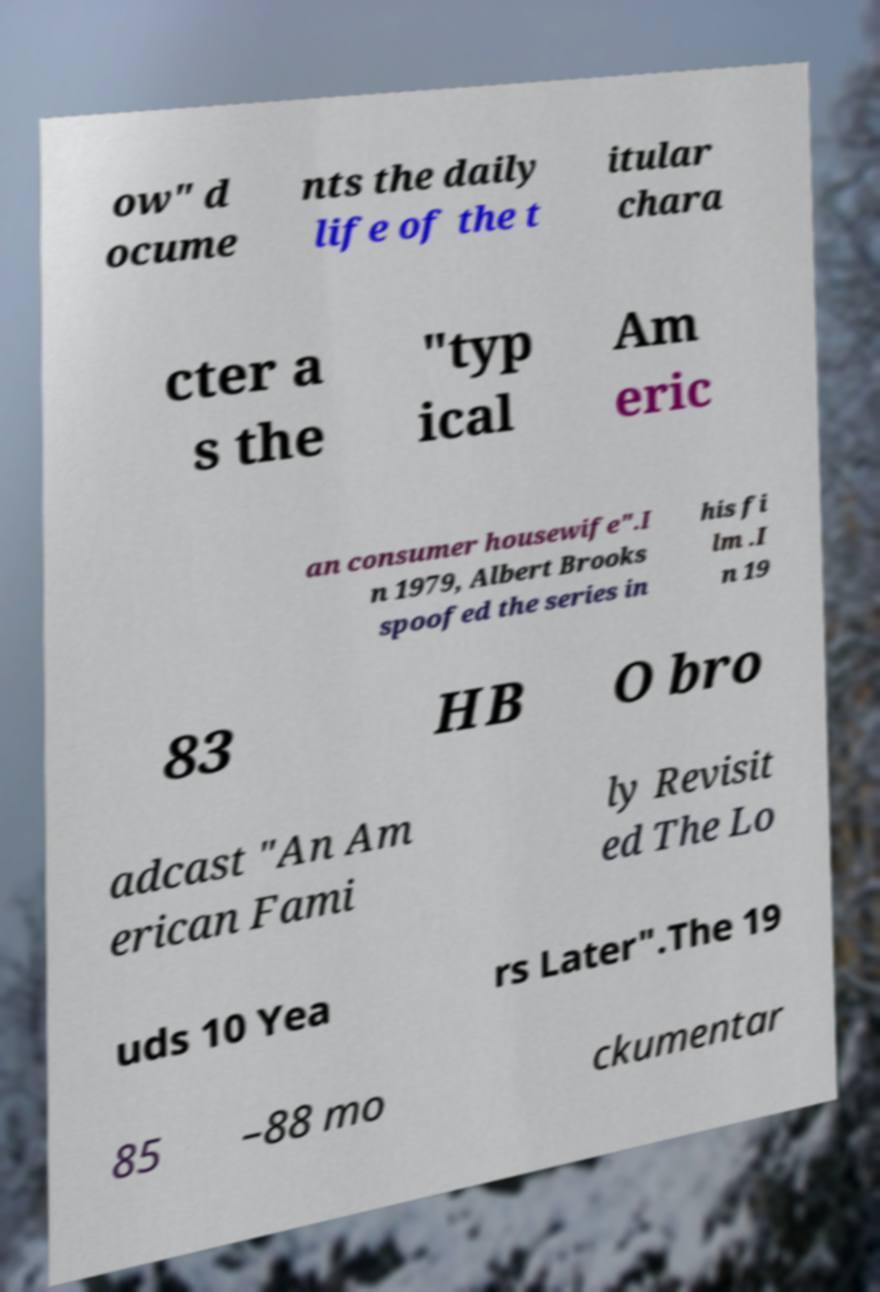Could you assist in decoding the text presented in this image and type it out clearly? ow" d ocume nts the daily life of the t itular chara cter a s the "typ ical Am eric an consumer housewife".I n 1979, Albert Brooks spoofed the series in his fi lm .I n 19 83 HB O bro adcast "An Am erican Fami ly Revisit ed The Lo uds 10 Yea rs Later".The 19 85 –88 mo ckumentar 